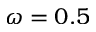<formula> <loc_0><loc_0><loc_500><loc_500>\omega = 0 . 5</formula> 